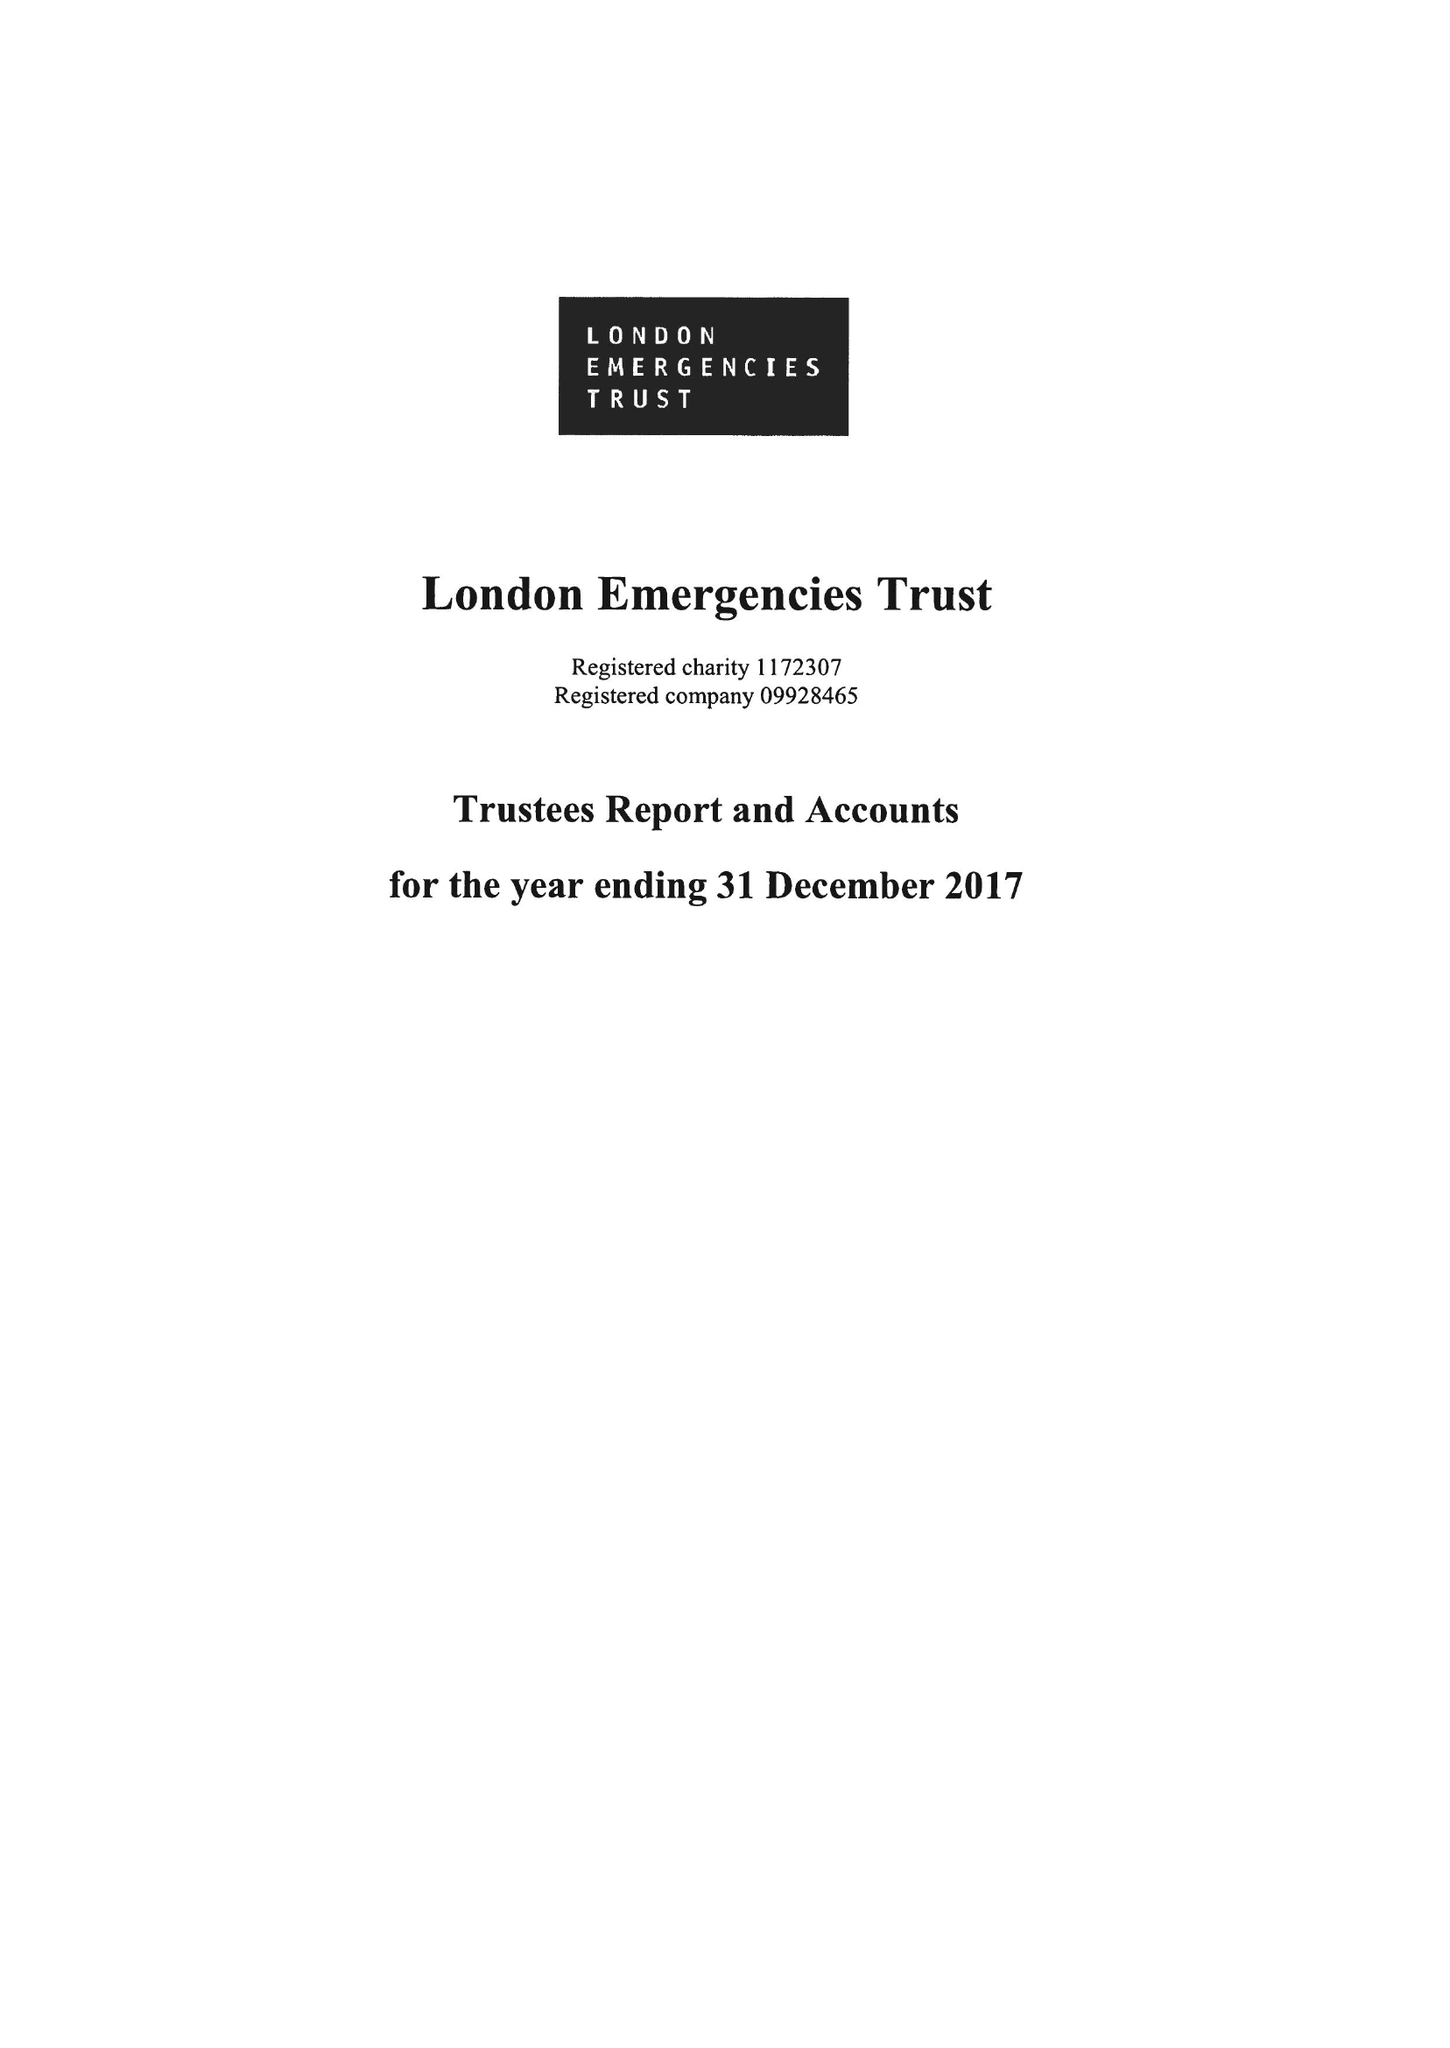What is the value for the spending_annually_in_british_pounds?
Answer the question using a single word or phrase. 9755003.00 